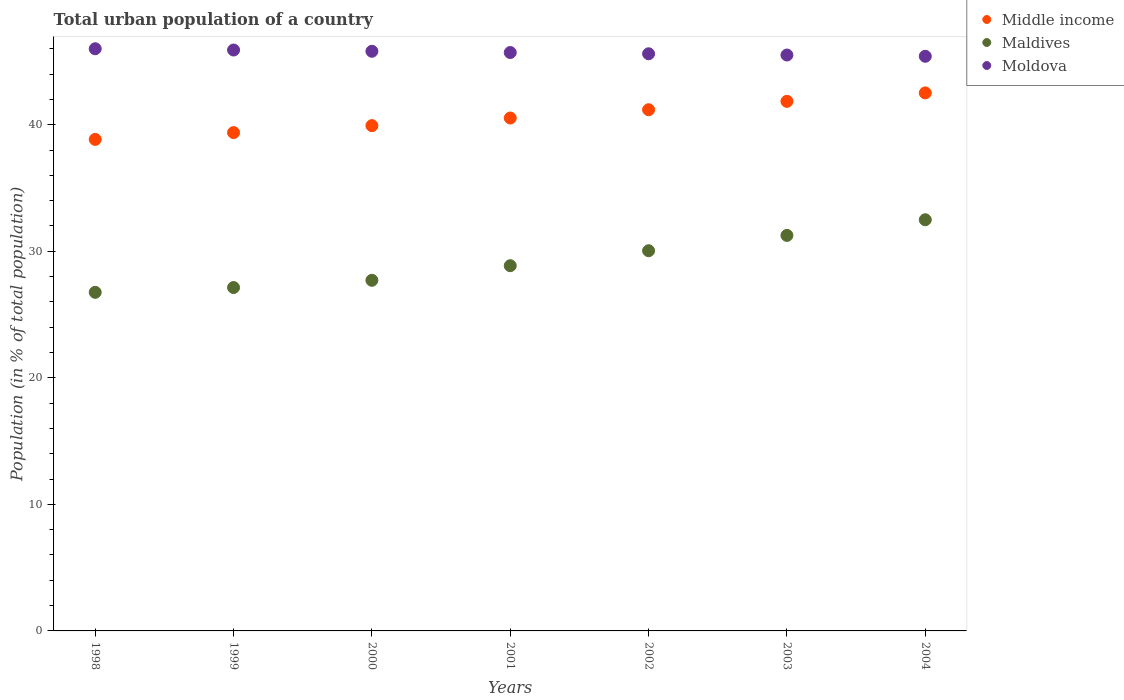What is the urban population in Middle income in 1999?
Make the answer very short. 39.38. Across all years, what is the maximum urban population in Moldova?
Your answer should be very brief. 46. Across all years, what is the minimum urban population in Maldives?
Make the answer very short. 26.75. In which year was the urban population in Moldova maximum?
Provide a succinct answer. 1998. What is the total urban population in Maldives in the graph?
Your answer should be very brief. 204.24. What is the difference between the urban population in Maldives in 1998 and that in 2002?
Your answer should be very brief. -3.29. What is the difference between the urban population in Middle income in 1998 and the urban population in Moldova in 2001?
Make the answer very short. -6.86. What is the average urban population in Maldives per year?
Your response must be concise. 29.18. In the year 2002, what is the difference between the urban population in Moldova and urban population in Middle income?
Ensure brevity in your answer.  4.42. What is the ratio of the urban population in Middle income in 2003 to that in 2004?
Your answer should be compact. 0.98. Is the difference between the urban population in Moldova in 2002 and 2003 greater than the difference between the urban population in Middle income in 2002 and 2003?
Provide a short and direct response. Yes. What is the difference between the highest and the second highest urban population in Moldova?
Offer a very short reply. 0.1. What is the difference between the highest and the lowest urban population in Moldova?
Give a very brief answer. 0.6. Is the sum of the urban population in Moldova in 2001 and 2002 greater than the maximum urban population in Middle income across all years?
Keep it short and to the point. Yes. Is it the case that in every year, the sum of the urban population in Moldova and urban population in Maldives  is greater than the urban population in Middle income?
Give a very brief answer. Yes. Does the urban population in Maldives monotonically increase over the years?
Offer a terse response. Yes. Is the urban population in Middle income strictly less than the urban population in Moldova over the years?
Make the answer very short. Yes. Are the values on the major ticks of Y-axis written in scientific E-notation?
Offer a terse response. No. Does the graph contain grids?
Offer a very short reply. No. Where does the legend appear in the graph?
Make the answer very short. Top right. What is the title of the graph?
Your answer should be very brief. Total urban population of a country. Does "Kuwait" appear as one of the legend labels in the graph?
Make the answer very short. No. What is the label or title of the X-axis?
Provide a short and direct response. Years. What is the label or title of the Y-axis?
Provide a succinct answer. Population (in % of total population). What is the Population (in % of total population) of Middle income in 1998?
Offer a very short reply. 38.84. What is the Population (in % of total population) in Maldives in 1998?
Your response must be concise. 26.75. What is the Population (in % of total population) of Moldova in 1998?
Your response must be concise. 46. What is the Population (in % of total population) of Middle income in 1999?
Keep it short and to the point. 39.38. What is the Population (in % of total population) of Maldives in 1999?
Your answer should be compact. 27.13. What is the Population (in % of total population) of Moldova in 1999?
Keep it short and to the point. 45.9. What is the Population (in % of total population) of Middle income in 2000?
Your answer should be compact. 39.93. What is the Population (in % of total population) in Maldives in 2000?
Make the answer very short. 27.71. What is the Population (in % of total population) in Moldova in 2000?
Your response must be concise. 45.8. What is the Population (in % of total population) of Middle income in 2001?
Offer a terse response. 40.53. What is the Population (in % of total population) of Maldives in 2001?
Keep it short and to the point. 28.86. What is the Population (in % of total population) in Moldova in 2001?
Provide a short and direct response. 45.7. What is the Population (in % of total population) of Middle income in 2002?
Offer a very short reply. 41.18. What is the Population (in % of total population) of Maldives in 2002?
Offer a terse response. 30.04. What is the Population (in % of total population) in Moldova in 2002?
Your response must be concise. 45.6. What is the Population (in % of total population) in Middle income in 2003?
Give a very brief answer. 41.85. What is the Population (in % of total population) of Maldives in 2003?
Give a very brief answer. 31.25. What is the Population (in % of total population) of Moldova in 2003?
Offer a terse response. 45.51. What is the Population (in % of total population) of Middle income in 2004?
Offer a terse response. 42.51. What is the Population (in % of total population) in Maldives in 2004?
Provide a short and direct response. 32.49. What is the Population (in % of total population) in Moldova in 2004?
Offer a very short reply. 45.41. Across all years, what is the maximum Population (in % of total population) of Middle income?
Ensure brevity in your answer.  42.51. Across all years, what is the maximum Population (in % of total population) in Maldives?
Provide a short and direct response. 32.49. Across all years, what is the maximum Population (in % of total population) in Moldova?
Provide a succinct answer. 46. Across all years, what is the minimum Population (in % of total population) of Middle income?
Your answer should be compact. 38.84. Across all years, what is the minimum Population (in % of total population) of Maldives?
Offer a terse response. 26.75. Across all years, what is the minimum Population (in % of total population) of Moldova?
Your response must be concise. 45.41. What is the total Population (in % of total population) in Middle income in the graph?
Make the answer very short. 284.22. What is the total Population (in % of total population) of Maldives in the graph?
Provide a short and direct response. 204.24. What is the total Population (in % of total population) of Moldova in the graph?
Your answer should be compact. 319.93. What is the difference between the Population (in % of total population) of Middle income in 1998 and that in 1999?
Your answer should be compact. -0.54. What is the difference between the Population (in % of total population) in Maldives in 1998 and that in 1999?
Make the answer very short. -0.38. What is the difference between the Population (in % of total population) of Moldova in 1998 and that in 1999?
Provide a succinct answer. 0.1. What is the difference between the Population (in % of total population) in Middle income in 1998 and that in 2000?
Make the answer very short. -1.09. What is the difference between the Population (in % of total population) in Maldives in 1998 and that in 2000?
Provide a succinct answer. -0.95. What is the difference between the Population (in % of total population) in Moldova in 1998 and that in 2000?
Offer a very short reply. 0.2. What is the difference between the Population (in % of total population) in Middle income in 1998 and that in 2001?
Keep it short and to the point. -1.69. What is the difference between the Population (in % of total population) of Maldives in 1998 and that in 2001?
Ensure brevity in your answer.  -2.1. What is the difference between the Population (in % of total population) in Moldova in 1998 and that in 2001?
Offer a terse response. 0.3. What is the difference between the Population (in % of total population) in Middle income in 1998 and that in 2002?
Provide a short and direct response. -2.35. What is the difference between the Population (in % of total population) of Maldives in 1998 and that in 2002?
Offer a very short reply. -3.29. What is the difference between the Population (in % of total population) in Moldova in 1998 and that in 2002?
Provide a short and direct response. 0.4. What is the difference between the Population (in % of total population) in Middle income in 1998 and that in 2003?
Keep it short and to the point. -3.01. What is the difference between the Population (in % of total population) of Maldives in 1998 and that in 2003?
Make the answer very short. -4.5. What is the difference between the Population (in % of total population) of Moldova in 1998 and that in 2003?
Offer a terse response. 0.5. What is the difference between the Population (in % of total population) of Middle income in 1998 and that in 2004?
Your answer should be very brief. -3.67. What is the difference between the Population (in % of total population) of Maldives in 1998 and that in 2004?
Provide a short and direct response. -5.74. What is the difference between the Population (in % of total population) in Moldova in 1998 and that in 2004?
Your answer should be very brief. 0.59. What is the difference between the Population (in % of total population) in Middle income in 1999 and that in 2000?
Offer a terse response. -0.55. What is the difference between the Population (in % of total population) in Maldives in 1999 and that in 2000?
Your answer should be compact. -0.57. What is the difference between the Population (in % of total population) in Moldova in 1999 and that in 2000?
Ensure brevity in your answer.  0.1. What is the difference between the Population (in % of total population) of Middle income in 1999 and that in 2001?
Provide a succinct answer. -1.15. What is the difference between the Population (in % of total population) of Maldives in 1999 and that in 2001?
Ensure brevity in your answer.  -1.73. What is the difference between the Population (in % of total population) in Moldova in 1999 and that in 2001?
Provide a short and direct response. 0.2. What is the difference between the Population (in % of total population) in Middle income in 1999 and that in 2002?
Your response must be concise. -1.81. What is the difference between the Population (in % of total population) of Maldives in 1999 and that in 2002?
Offer a very short reply. -2.91. What is the difference between the Population (in % of total population) of Moldova in 1999 and that in 2002?
Your answer should be very brief. 0.3. What is the difference between the Population (in % of total population) of Middle income in 1999 and that in 2003?
Offer a terse response. -2.47. What is the difference between the Population (in % of total population) of Maldives in 1999 and that in 2003?
Give a very brief answer. -4.12. What is the difference between the Population (in % of total population) of Moldova in 1999 and that in 2003?
Provide a short and direct response. 0.4. What is the difference between the Population (in % of total population) in Middle income in 1999 and that in 2004?
Provide a short and direct response. -3.14. What is the difference between the Population (in % of total population) of Maldives in 1999 and that in 2004?
Your answer should be compact. -5.36. What is the difference between the Population (in % of total population) of Moldova in 1999 and that in 2004?
Keep it short and to the point. 0.49. What is the difference between the Population (in % of total population) in Middle income in 2000 and that in 2001?
Give a very brief answer. -0.6. What is the difference between the Population (in % of total population) of Maldives in 2000 and that in 2001?
Offer a very short reply. -1.15. What is the difference between the Population (in % of total population) of Moldova in 2000 and that in 2001?
Offer a terse response. 0.1. What is the difference between the Population (in % of total population) of Middle income in 2000 and that in 2002?
Offer a terse response. -1.26. What is the difference between the Population (in % of total population) in Maldives in 2000 and that in 2002?
Offer a terse response. -2.34. What is the difference between the Population (in % of total population) of Moldova in 2000 and that in 2002?
Make the answer very short. 0.2. What is the difference between the Population (in % of total population) of Middle income in 2000 and that in 2003?
Offer a very short reply. -1.92. What is the difference between the Population (in % of total population) of Maldives in 2000 and that in 2003?
Provide a succinct answer. -3.55. What is the difference between the Population (in % of total population) in Moldova in 2000 and that in 2003?
Keep it short and to the point. 0.3. What is the difference between the Population (in % of total population) of Middle income in 2000 and that in 2004?
Offer a terse response. -2.59. What is the difference between the Population (in % of total population) of Maldives in 2000 and that in 2004?
Give a very brief answer. -4.78. What is the difference between the Population (in % of total population) of Moldova in 2000 and that in 2004?
Keep it short and to the point. 0.4. What is the difference between the Population (in % of total population) in Middle income in 2001 and that in 2002?
Your answer should be very brief. -0.66. What is the difference between the Population (in % of total population) of Maldives in 2001 and that in 2002?
Keep it short and to the point. -1.18. What is the difference between the Population (in % of total population) in Moldova in 2001 and that in 2002?
Offer a very short reply. 0.1. What is the difference between the Population (in % of total population) of Middle income in 2001 and that in 2003?
Your response must be concise. -1.32. What is the difference between the Population (in % of total population) of Maldives in 2001 and that in 2003?
Make the answer very short. -2.39. What is the difference between the Population (in % of total population) in Moldova in 2001 and that in 2003?
Your response must be concise. 0.2. What is the difference between the Population (in % of total population) in Middle income in 2001 and that in 2004?
Keep it short and to the point. -1.98. What is the difference between the Population (in % of total population) in Maldives in 2001 and that in 2004?
Keep it short and to the point. -3.63. What is the difference between the Population (in % of total population) of Moldova in 2001 and that in 2004?
Give a very brief answer. 0.3. What is the difference between the Population (in % of total population) of Middle income in 2002 and that in 2003?
Provide a succinct answer. -0.66. What is the difference between the Population (in % of total population) of Maldives in 2002 and that in 2003?
Give a very brief answer. -1.21. What is the difference between the Population (in % of total population) of Moldova in 2002 and that in 2003?
Keep it short and to the point. 0.1. What is the difference between the Population (in % of total population) in Middle income in 2002 and that in 2004?
Your answer should be very brief. -1.33. What is the difference between the Population (in % of total population) of Maldives in 2002 and that in 2004?
Give a very brief answer. -2.45. What is the difference between the Population (in % of total population) in Moldova in 2002 and that in 2004?
Keep it short and to the point. 0.2. What is the difference between the Population (in % of total population) in Middle income in 2003 and that in 2004?
Offer a very short reply. -0.67. What is the difference between the Population (in % of total population) of Maldives in 2003 and that in 2004?
Make the answer very short. -1.24. What is the difference between the Population (in % of total population) of Moldova in 2003 and that in 2004?
Provide a short and direct response. 0.1. What is the difference between the Population (in % of total population) in Middle income in 1998 and the Population (in % of total population) in Maldives in 1999?
Your answer should be compact. 11.71. What is the difference between the Population (in % of total population) of Middle income in 1998 and the Population (in % of total population) of Moldova in 1999?
Keep it short and to the point. -7.06. What is the difference between the Population (in % of total population) in Maldives in 1998 and the Population (in % of total population) in Moldova in 1999?
Offer a very short reply. -19.15. What is the difference between the Population (in % of total population) in Middle income in 1998 and the Population (in % of total population) in Maldives in 2000?
Your response must be concise. 11.13. What is the difference between the Population (in % of total population) of Middle income in 1998 and the Population (in % of total population) of Moldova in 2000?
Offer a terse response. -6.96. What is the difference between the Population (in % of total population) in Maldives in 1998 and the Population (in % of total population) in Moldova in 2000?
Your answer should be very brief. -19.05. What is the difference between the Population (in % of total population) in Middle income in 1998 and the Population (in % of total population) in Maldives in 2001?
Make the answer very short. 9.98. What is the difference between the Population (in % of total population) in Middle income in 1998 and the Population (in % of total population) in Moldova in 2001?
Offer a terse response. -6.86. What is the difference between the Population (in % of total population) of Maldives in 1998 and the Population (in % of total population) of Moldova in 2001?
Your response must be concise. -18.95. What is the difference between the Population (in % of total population) of Middle income in 1998 and the Population (in % of total population) of Maldives in 2002?
Keep it short and to the point. 8.8. What is the difference between the Population (in % of total population) of Middle income in 1998 and the Population (in % of total population) of Moldova in 2002?
Offer a terse response. -6.77. What is the difference between the Population (in % of total population) of Maldives in 1998 and the Population (in % of total population) of Moldova in 2002?
Give a very brief answer. -18.85. What is the difference between the Population (in % of total population) of Middle income in 1998 and the Population (in % of total population) of Maldives in 2003?
Make the answer very short. 7.59. What is the difference between the Population (in % of total population) of Middle income in 1998 and the Population (in % of total population) of Moldova in 2003?
Offer a very short reply. -6.67. What is the difference between the Population (in % of total population) in Maldives in 1998 and the Population (in % of total population) in Moldova in 2003?
Offer a very short reply. -18.75. What is the difference between the Population (in % of total population) of Middle income in 1998 and the Population (in % of total population) of Maldives in 2004?
Provide a short and direct response. 6.35. What is the difference between the Population (in % of total population) in Middle income in 1998 and the Population (in % of total population) in Moldova in 2004?
Offer a very short reply. -6.57. What is the difference between the Population (in % of total population) of Maldives in 1998 and the Population (in % of total population) of Moldova in 2004?
Make the answer very short. -18.65. What is the difference between the Population (in % of total population) of Middle income in 1999 and the Population (in % of total population) of Maldives in 2000?
Provide a succinct answer. 11.67. What is the difference between the Population (in % of total population) of Middle income in 1999 and the Population (in % of total population) of Moldova in 2000?
Give a very brief answer. -6.43. What is the difference between the Population (in % of total population) in Maldives in 1999 and the Population (in % of total population) in Moldova in 2000?
Give a very brief answer. -18.67. What is the difference between the Population (in % of total population) in Middle income in 1999 and the Population (in % of total population) in Maldives in 2001?
Provide a succinct answer. 10.52. What is the difference between the Population (in % of total population) of Middle income in 1999 and the Population (in % of total population) of Moldova in 2001?
Give a very brief answer. -6.33. What is the difference between the Population (in % of total population) of Maldives in 1999 and the Population (in % of total population) of Moldova in 2001?
Keep it short and to the point. -18.57. What is the difference between the Population (in % of total population) in Middle income in 1999 and the Population (in % of total population) in Maldives in 2002?
Your answer should be compact. 9.34. What is the difference between the Population (in % of total population) of Middle income in 1999 and the Population (in % of total population) of Moldova in 2002?
Make the answer very short. -6.23. What is the difference between the Population (in % of total population) of Maldives in 1999 and the Population (in % of total population) of Moldova in 2002?
Make the answer very short. -18.47. What is the difference between the Population (in % of total population) of Middle income in 1999 and the Population (in % of total population) of Maldives in 2003?
Your response must be concise. 8.13. What is the difference between the Population (in % of total population) in Middle income in 1999 and the Population (in % of total population) in Moldova in 2003?
Give a very brief answer. -6.13. What is the difference between the Population (in % of total population) in Maldives in 1999 and the Population (in % of total population) in Moldova in 2003?
Make the answer very short. -18.37. What is the difference between the Population (in % of total population) in Middle income in 1999 and the Population (in % of total population) in Maldives in 2004?
Make the answer very short. 6.89. What is the difference between the Population (in % of total population) in Middle income in 1999 and the Population (in % of total population) in Moldova in 2004?
Your answer should be compact. -6.03. What is the difference between the Population (in % of total population) in Maldives in 1999 and the Population (in % of total population) in Moldova in 2004?
Your answer should be very brief. -18.27. What is the difference between the Population (in % of total population) of Middle income in 2000 and the Population (in % of total population) of Maldives in 2001?
Your answer should be very brief. 11.07. What is the difference between the Population (in % of total population) of Middle income in 2000 and the Population (in % of total population) of Moldova in 2001?
Your answer should be compact. -5.78. What is the difference between the Population (in % of total population) in Maldives in 2000 and the Population (in % of total population) in Moldova in 2001?
Give a very brief answer. -18. What is the difference between the Population (in % of total population) in Middle income in 2000 and the Population (in % of total population) in Maldives in 2002?
Ensure brevity in your answer.  9.88. What is the difference between the Population (in % of total population) in Middle income in 2000 and the Population (in % of total population) in Moldova in 2002?
Provide a short and direct response. -5.68. What is the difference between the Population (in % of total population) in Maldives in 2000 and the Population (in % of total population) in Moldova in 2002?
Your answer should be compact. -17.9. What is the difference between the Population (in % of total population) in Middle income in 2000 and the Population (in % of total population) in Maldives in 2003?
Your answer should be compact. 8.67. What is the difference between the Population (in % of total population) of Middle income in 2000 and the Population (in % of total population) of Moldova in 2003?
Your answer should be compact. -5.58. What is the difference between the Population (in % of total population) in Maldives in 2000 and the Population (in % of total population) in Moldova in 2003?
Provide a short and direct response. -17.8. What is the difference between the Population (in % of total population) of Middle income in 2000 and the Population (in % of total population) of Maldives in 2004?
Ensure brevity in your answer.  7.44. What is the difference between the Population (in % of total population) in Middle income in 2000 and the Population (in % of total population) in Moldova in 2004?
Offer a very short reply. -5.48. What is the difference between the Population (in % of total population) of Maldives in 2000 and the Population (in % of total population) of Moldova in 2004?
Keep it short and to the point. -17.7. What is the difference between the Population (in % of total population) of Middle income in 2001 and the Population (in % of total population) of Maldives in 2002?
Your answer should be compact. 10.49. What is the difference between the Population (in % of total population) in Middle income in 2001 and the Population (in % of total population) in Moldova in 2002?
Offer a terse response. -5.08. What is the difference between the Population (in % of total population) in Maldives in 2001 and the Population (in % of total population) in Moldova in 2002?
Ensure brevity in your answer.  -16.75. What is the difference between the Population (in % of total population) in Middle income in 2001 and the Population (in % of total population) in Maldives in 2003?
Give a very brief answer. 9.28. What is the difference between the Population (in % of total population) in Middle income in 2001 and the Population (in % of total population) in Moldova in 2003?
Give a very brief answer. -4.98. What is the difference between the Population (in % of total population) of Maldives in 2001 and the Population (in % of total population) of Moldova in 2003?
Give a very brief answer. -16.65. What is the difference between the Population (in % of total population) in Middle income in 2001 and the Population (in % of total population) in Maldives in 2004?
Keep it short and to the point. 8.04. What is the difference between the Population (in % of total population) in Middle income in 2001 and the Population (in % of total population) in Moldova in 2004?
Ensure brevity in your answer.  -4.88. What is the difference between the Population (in % of total population) of Maldives in 2001 and the Population (in % of total population) of Moldova in 2004?
Your answer should be compact. -16.55. What is the difference between the Population (in % of total population) of Middle income in 2002 and the Population (in % of total population) of Maldives in 2003?
Keep it short and to the point. 9.93. What is the difference between the Population (in % of total population) of Middle income in 2002 and the Population (in % of total population) of Moldova in 2003?
Your response must be concise. -4.32. What is the difference between the Population (in % of total population) in Maldives in 2002 and the Population (in % of total population) in Moldova in 2003?
Your response must be concise. -15.46. What is the difference between the Population (in % of total population) of Middle income in 2002 and the Population (in % of total population) of Maldives in 2004?
Give a very brief answer. 8.69. What is the difference between the Population (in % of total population) of Middle income in 2002 and the Population (in % of total population) of Moldova in 2004?
Provide a short and direct response. -4.22. What is the difference between the Population (in % of total population) in Maldives in 2002 and the Population (in % of total population) in Moldova in 2004?
Offer a very short reply. -15.37. What is the difference between the Population (in % of total population) in Middle income in 2003 and the Population (in % of total population) in Maldives in 2004?
Keep it short and to the point. 9.36. What is the difference between the Population (in % of total population) of Middle income in 2003 and the Population (in % of total population) of Moldova in 2004?
Offer a very short reply. -3.56. What is the difference between the Population (in % of total population) of Maldives in 2003 and the Population (in % of total population) of Moldova in 2004?
Offer a terse response. -14.15. What is the average Population (in % of total population) of Middle income per year?
Offer a very short reply. 40.6. What is the average Population (in % of total population) in Maldives per year?
Your response must be concise. 29.18. What is the average Population (in % of total population) of Moldova per year?
Offer a very short reply. 45.7. In the year 1998, what is the difference between the Population (in % of total population) in Middle income and Population (in % of total population) in Maldives?
Offer a very short reply. 12.08. In the year 1998, what is the difference between the Population (in % of total population) of Middle income and Population (in % of total population) of Moldova?
Offer a terse response. -7.16. In the year 1998, what is the difference between the Population (in % of total population) in Maldives and Population (in % of total population) in Moldova?
Offer a very short reply. -19.25. In the year 1999, what is the difference between the Population (in % of total population) of Middle income and Population (in % of total population) of Maldives?
Your response must be concise. 12.24. In the year 1999, what is the difference between the Population (in % of total population) of Middle income and Population (in % of total population) of Moldova?
Your answer should be compact. -6.52. In the year 1999, what is the difference between the Population (in % of total population) of Maldives and Population (in % of total population) of Moldova?
Give a very brief answer. -18.77. In the year 2000, what is the difference between the Population (in % of total population) of Middle income and Population (in % of total population) of Maldives?
Your answer should be very brief. 12.22. In the year 2000, what is the difference between the Population (in % of total population) in Middle income and Population (in % of total population) in Moldova?
Offer a terse response. -5.88. In the year 2000, what is the difference between the Population (in % of total population) in Maldives and Population (in % of total population) in Moldova?
Give a very brief answer. -18.1. In the year 2001, what is the difference between the Population (in % of total population) in Middle income and Population (in % of total population) in Maldives?
Provide a succinct answer. 11.67. In the year 2001, what is the difference between the Population (in % of total population) in Middle income and Population (in % of total population) in Moldova?
Keep it short and to the point. -5.17. In the year 2001, what is the difference between the Population (in % of total population) in Maldives and Population (in % of total population) in Moldova?
Offer a very short reply. -16.84. In the year 2002, what is the difference between the Population (in % of total population) in Middle income and Population (in % of total population) in Maldives?
Provide a short and direct response. 11.14. In the year 2002, what is the difference between the Population (in % of total population) in Middle income and Population (in % of total population) in Moldova?
Give a very brief answer. -4.42. In the year 2002, what is the difference between the Population (in % of total population) in Maldives and Population (in % of total population) in Moldova?
Give a very brief answer. -15.56. In the year 2003, what is the difference between the Population (in % of total population) of Middle income and Population (in % of total population) of Maldives?
Make the answer very short. 10.59. In the year 2003, what is the difference between the Population (in % of total population) in Middle income and Population (in % of total population) in Moldova?
Your response must be concise. -3.66. In the year 2003, what is the difference between the Population (in % of total population) of Maldives and Population (in % of total population) of Moldova?
Ensure brevity in your answer.  -14.25. In the year 2004, what is the difference between the Population (in % of total population) of Middle income and Population (in % of total population) of Maldives?
Offer a terse response. 10.02. In the year 2004, what is the difference between the Population (in % of total population) of Middle income and Population (in % of total population) of Moldova?
Keep it short and to the point. -2.89. In the year 2004, what is the difference between the Population (in % of total population) in Maldives and Population (in % of total population) in Moldova?
Your answer should be very brief. -12.92. What is the ratio of the Population (in % of total population) of Middle income in 1998 to that in 1999?
Keep it short and to the point. 0.99. What is the ratio of the Population (in % of total population) of Maldives in 1998 to that in 1999?
Your answer should be compact. 0.99. What is the ratio of the Population (in % of total population) of Middle income in 1998 to that in 2000?
Keep it short and to the point. 0.97. What is the ratio of the Population (in % of total population) of Maldives in 1998 to that in 2000?
Make the answer very short. 0.97. What is the ratio of the Population (in % of total population) of Moldova in 1998 to that in 2000?
Offer a very short reply. 1. What is the ratio of the Population (in % of total population) in Middle income in 1998 to that in 2001?
Offer a terse response. 0.96. What is the ratio of the Population (in % of total population) of Maldives in 1998 to that in 2001?
Keep it short and to the point. 0.93. What is the ratio of the Population (in % of total population) in Middle income in 1998 to that in 2002?
Your answer should be compact. 0.94. What is the ratio of the Population (in % of total population) of Maldives in 1998 to that in 2002?
Provide a succinct answer. 0.89. What is the ratio of the Population (in % of total population) of Moldova in 1998 to that in 2002?
Provide a short and direct response. 1.01. What is the ratio of the Population (in % of total population) of Middle income in 1998 to that in 2003?
Your answer should be compact. 0.93. What is the ratio of the Population (in % of total population) of Maldives in 1998 to that in 2003?
Your response must be concise. 0.86. What is the ratio of the Population (in % of total population) in Moldova in 1998 to that in 2003?
Give a very brief answer. 1.01. What is the ratio of the Population (in % of total population) of Middle income in 1998 to that in 2004?
Your answer should be very brief. 0.91. What is the ratio of the Population (in % of total population) in Maldives in 1998 to that in 2004?
Your answer should be compact. 0.82. What is the ratio of the Population (in % of total population) in Moldova in 1998 to that in 2004?
Offer a terse response. 1.01. What is the ratio of the Population (in % of total population) in Middle income in 1999 to that in 2000?
Ensure brevity in your answer.  0.99. What is the ratio of the Population (in % of total population) in Maldives in 1999 to that in 2000?
Your answer should be very brief. 0.98. What is the ratio of the Population (in % of total population) in Moldova in 1999 to that in 2000?
Your answer should be compact. 1. What is the ratio of the Population (in % of total population) in Middle income in 1999 to that in 2001?
Make the answer very short. 0.97. What is the ratio of the Population (in % of total population) of Maldives in 1999 to that in 2001?
Make the answer very short. 0.94. What is the ratio of the Population (in % of total population) of Middle income in 1999 to that in 2002?
Give a very brief answer. 0.96. What is the ratio of the Population (in % of total population) of Maldives in 1999 to that in 2002?
Give a very brief answer. 0.9. What is the ratio of the Population (in % of total population) of Middle income in 1999 to that in 2003?
Offer a very short reply. 0.94. What is the ratio of the Population (in % of total population) of Maldives in 1999 to that in 2003?
Give a very brief answer. 0.87. What is the ratio of the Population (in % of total population) of Moldova in 1999 to that in 2003?
Provide a succinct answer. 1.01. What is the ratio of the Population (in % of total population) in Middle income in 1999 to that in 2004?
Offer a very short reply. 0.93. What is the ratio of the Population (in % of total population) in Maldives in 1999 to that in 2004?
Your answer should be compact. 0.84. What is the ratio of the Population (in % of total population) in Moldova in 1999 to that in 2004?
Make the answer very short. 1.01. What is the ratio of the Population (in % of total population) of Middle income in 2000 to that in 2001?
Your answer should be compact. 0.99. What is the ratio of the Population (in % of total population) of Maldives in 2000 to that in 2001?
Provide a short and direct response. 0.96. What is the ratio of the Population (in % of total population) in Moldova in 2000 to that in 2001?
Your response must be concise. 1. What is the ratio of the Population (in % of total population) in Middle income in 2000 to that in 2002?
Provide a succinct answer. 0.97. What is the ratio of the Population (in % of total population) of Maldives in 2000 to that in 2002?
Your response must be concise. 0.92. What is the ratio of the Population (in % of total population) in Moldova in 2000 to that in 2002?
Offer a terse response. 1. What is the ratio of the Population (in % of total population) in Middle income in 2000 to that in 2003?
Ensure brevity in your answer.  0.95. What is the ratio of the Population (in % of total population) of Maldives in 2000 to that in 2003?
Your answer should be compact. 0.89. What is the ratio of the Population (in % of total population) in Moldova in 2000 to that in 2003?
Give a very brief answer. 1.01. What is the ratio of the Population (in % of total population) in Middle income in 2000 to that in 2004?
Provide a succinct answer. 0.94. What is the ratio of the Population (in % of total population) in Maldives in 2000 to that in 2004?
Give a very brief answer. 0.85. What is the ratio of the Population (in % of total population) of Moldova in 2000 to that in 2004?
Your answer should be compact. 1.01. What is the ratio of the Population (in % of total population) of Middle income in 2001 to that in 2002?
Provide a succinct answer. 0.98. What is the ratio of the Population (in % of total population) of Maldives in 2001 to that in 2002?
Keep it short and to the point. 0.96. What is the ratio of the Population (in % of total population) in Middle income in 2001 to that in 2003?
Keep it short and to the point. 0.97. What is the ratio of the Population (in % of total population) in Maldives in 2001 to that in 2003?
Your answer should be compact. 0.92. What is the ratio of the Population (in % of total population) in Middle income in 2001 to that in 2004?
Offer a very short reply. 0.95. What is the ratio of the Population (in % of total population) in Maldives in 2001 to that in 2004?
Provide a short and direct response. 0.89. What is the ratio of the Population (in % of total population) of Moldova in 2001 to that in 2004?
Provide a short and direct response. 1.01. What is the ratio of the Population (in % of total population) in Middle income in 2002 to that in 2003?
Your answer should be compact. 0.98. What is the ratio of the Population (in % of total population) of Maldives in 2002 to that in 2003?
Your answer should be compact. 0.96. What is the ratio of the Population (in % of total population) in Moldova in 2002 to that in 2003?
Ensure brevity in your answer.  1. What is the ratio of the Population (in % of total population) in Middle income in 2002 to that in 2004?
Make the answer very short. 0.97. What is the ratio of the Population (in % of total population) in Maldives in 2002 to that in 2004?
Ensure brevity in your answer.  0.92. What is the ratio of the Population (in % of total population) in Moldova in 2002 to that in 2004?
Make the answer very short. 1. What is the ratio of the Population (in % of total population) of Middle income in 2003 to that in 2004?
Keep it short and to the point. 0.98. What is the ratio of the Population (in % of total population) of Maldives in 2003 to that in 2004?
Your response must be concise. 0.96. What is the ratio of the Population (in % of total population) of Moldova in 2003 to that in 2004?
Offer a very short reply. 1. What is the difference between the highest and the second highest Population (in % of total population) of Middle income?
Provide a short and direct response. 0.67. What is the difference between the highest and the second highest Population (in % of total population) in Maldives?
Offer a terse response. 1.24. What is the difference between the highest and the lowest Population (in % of total population) in Middle income?
Your answer should be compact. 3.67. What is the difference between the highest and the lowest Population (in % of total population) in Maldives?
Provide a short and direct response. 5.74. What is the difference between the highest and the lowest Population (in % of total population) of Moldova?
Provide a succinct answer. 0.59. 